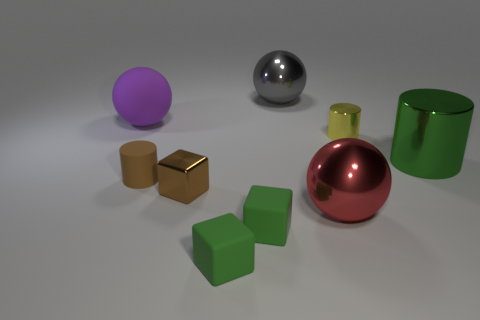Could you guess the purpose of this arrangement? Is it for display, education, or something else? It's hard to ascertain the precise purpose without more context, but the arrangement of the objects might be for aesthetic display, given their clean and simple presentation. Alternatively, this could be part of an educational set-up demonstrating concepts like geometry, color theory, or material properties.  Based on the light and shadows, what can you tell about the light source in this image? The light source in the image casts soft shadows directly underneath the objects, indicating that the light is positioned above them. The relatively soft edges of the shadows suggest that the light source is diffused, which could imply the use of studio lighting or a cloudy day if this were an outdoor setting. 